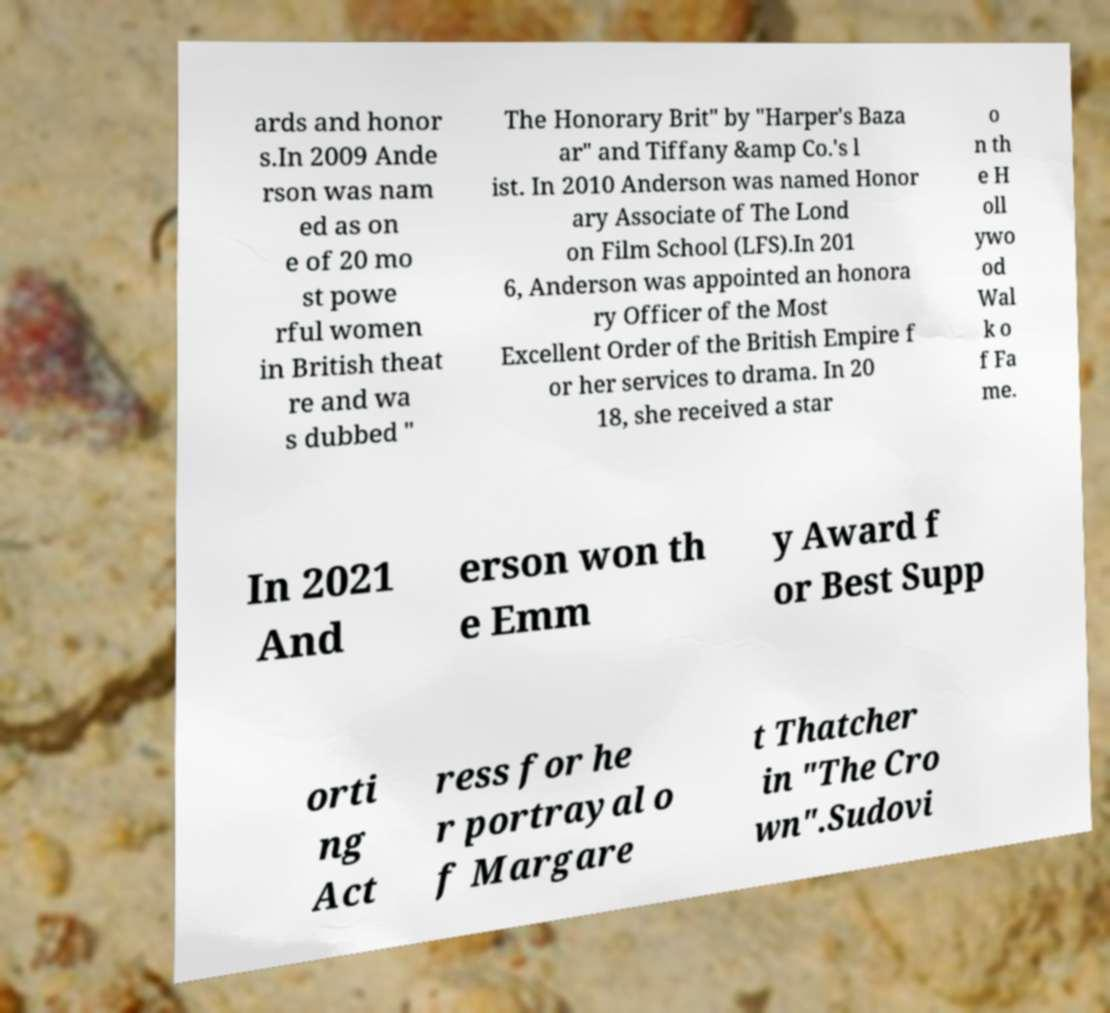For documentation purposes, I need the text within this image transcribed. Could you provide that? ards and honor s.In 2009 Ande rson was nam ed as on e of 20 mo st powe rful women in British theat re and wa s dubbed " The Honorary Brit" by "Harper's Baza ar" and Tiffany &amp Co.'s l ist. In 2010 Anderson was named Honor ary Associate of The Lond on Film School (LFS).In 201 6, Anderson was appointed an honora ry Officer of the Most Excellent Order of the British Empire f or her services to drama. In 20 18, she received a star o n th e H oll ywo od Wal k o f Fa me. In 2021 And erson won th e Emm y Award f or Best Supp orti ng Act ress for he r portrayal o f Margare t Thatcher in "The Cro wn".Sudovi 